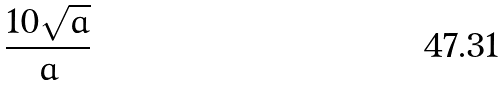<formula> <loc_0><loc_0><loc_500><loc_500>\frac { 1 0 \sqrt { a } } { a }</formula> 